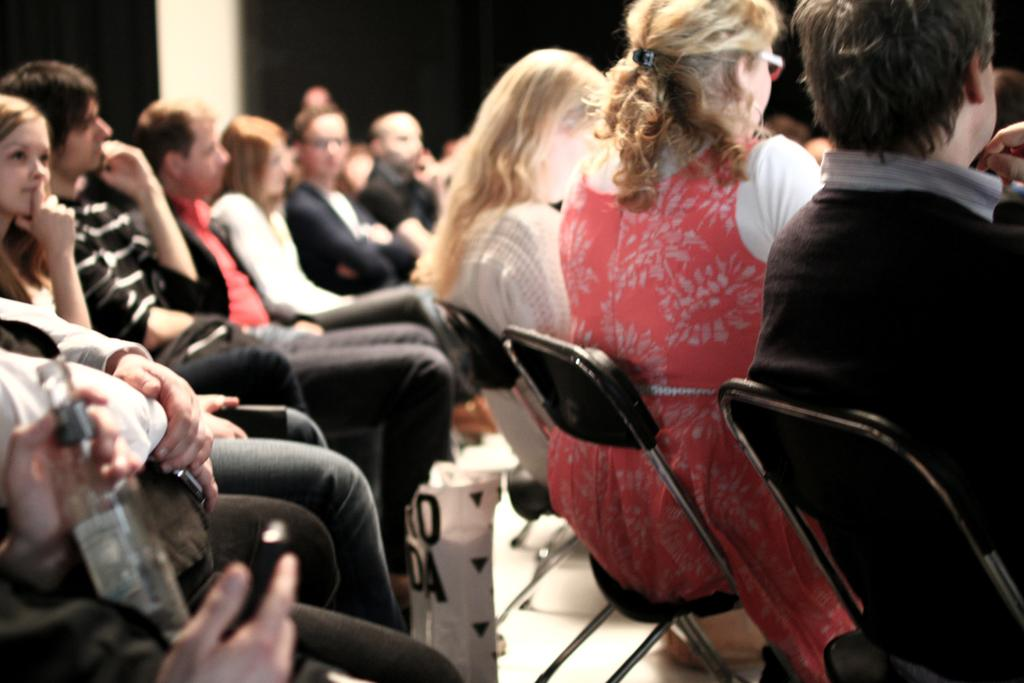Who or what can be seen in the image? There are people in the image. What are the people sitting on in the image? There are chairs in the image. Is there any object in the image that might contain a liquid? Yes, there is a bottle in the image. What theory is being discussed by the giants in the image? There are no giants present in the image, and therefore no such discussion can be observed. Can you describe the girl sitting on the chair in the image? There is no girl present in the image; only people are mentioned in the facts. 